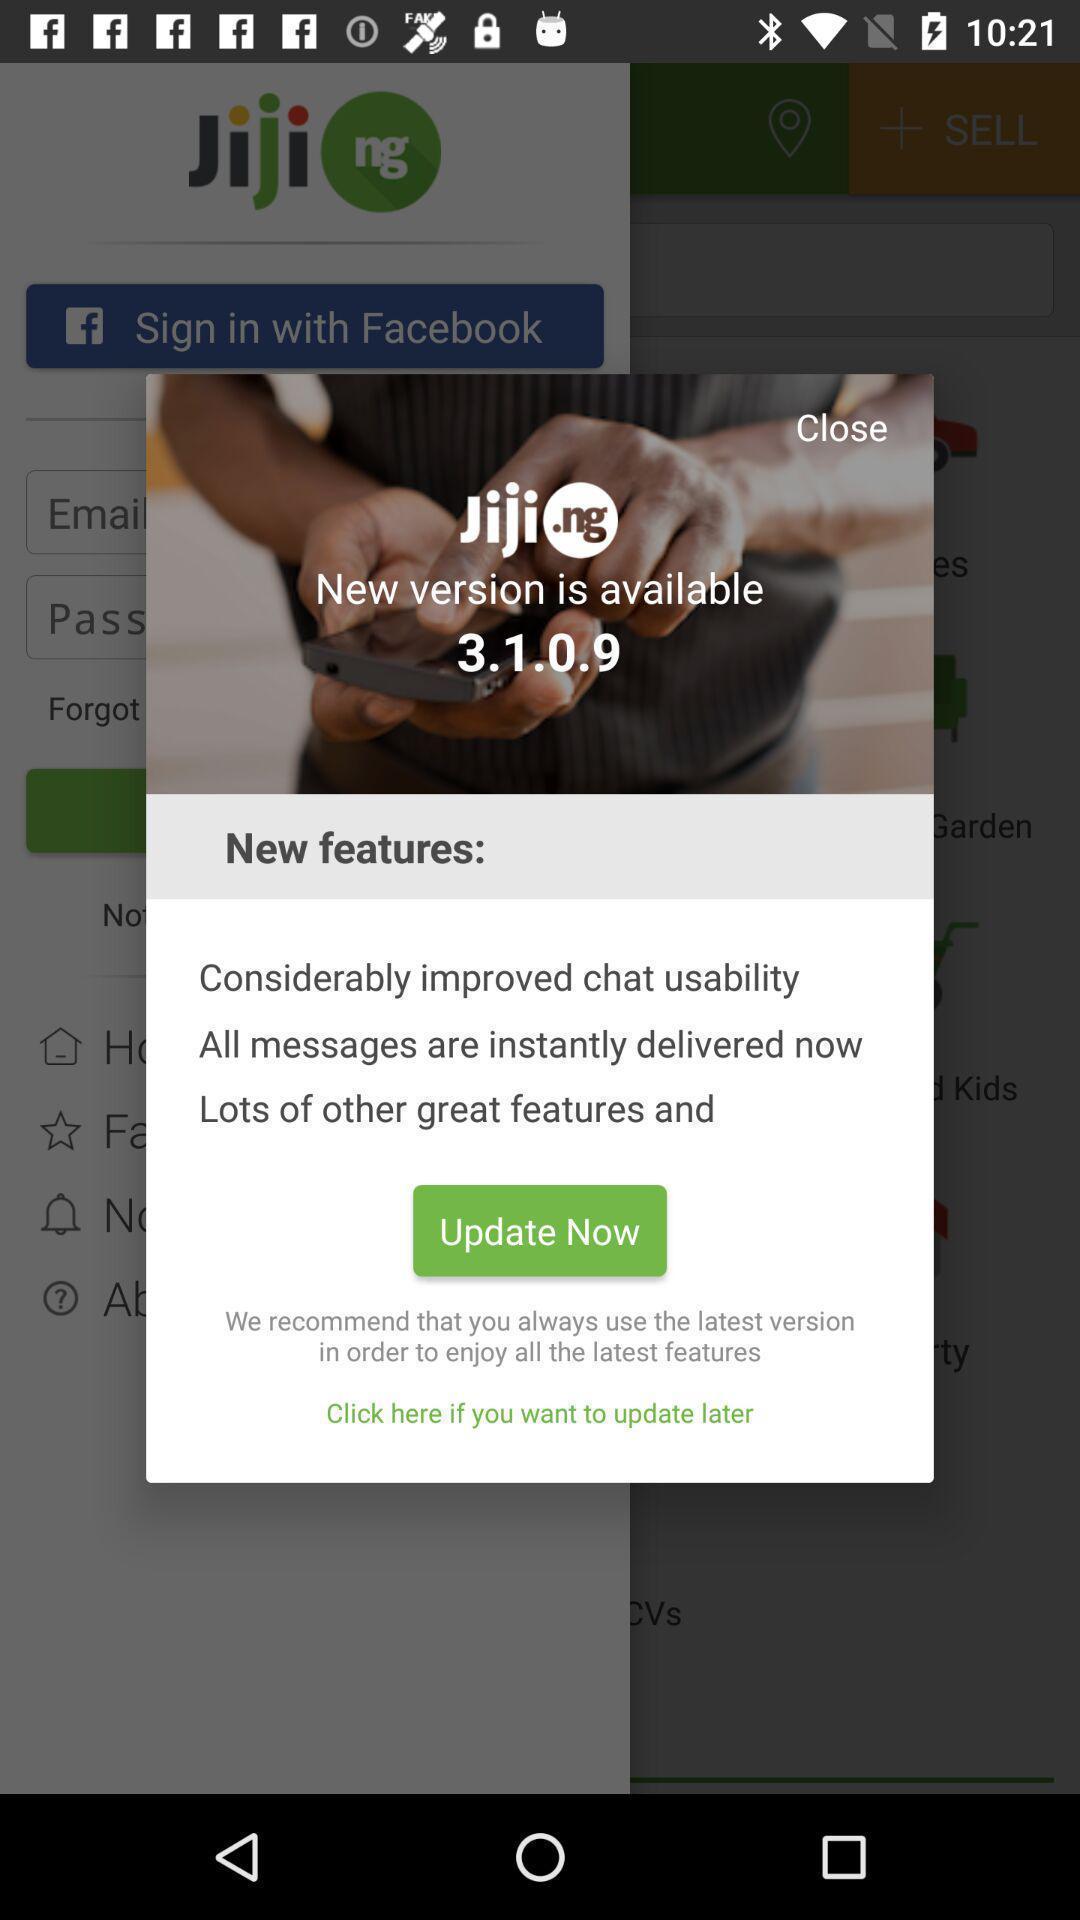Give me a narrative description of this picture. Pop-up to update application with new features. 